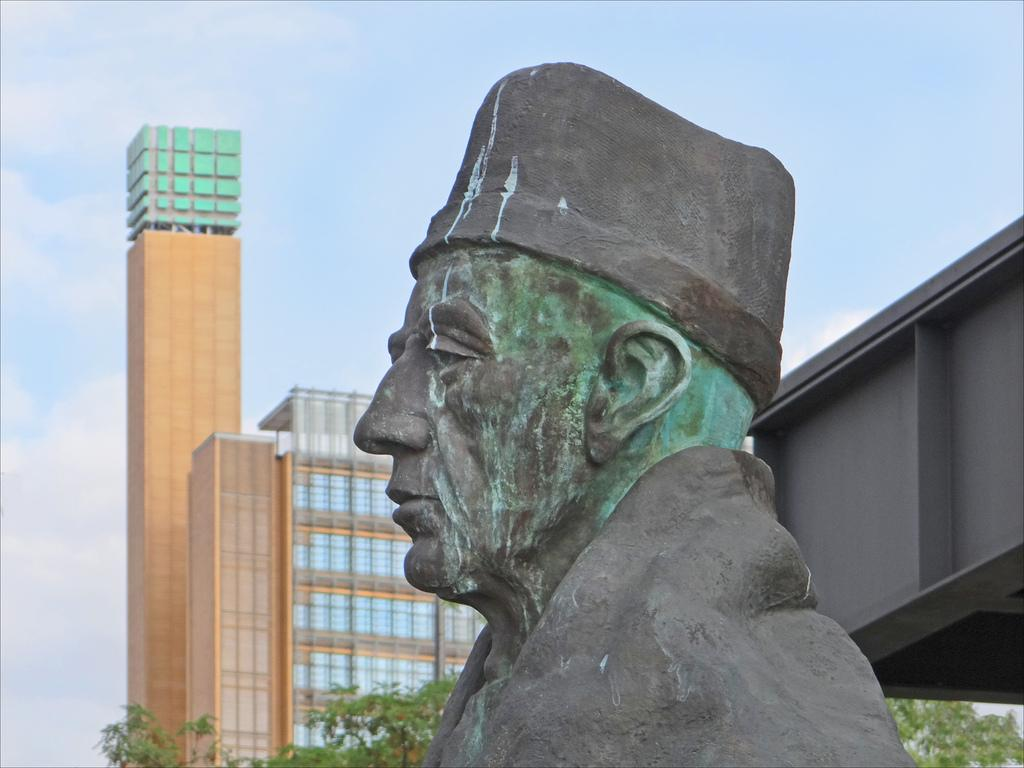What is the main subject of the image? There is a sculpture of a person in the image. What else can be seen in the image besides the sculpture? There is a building and a tree in the image. How would you describe the sky in the image? The sky is cloudy in the image. What type of wrench is being used to adjust the steam coming from the sculpture in the image? There is no wrench or steam present in the image; it features a sculpture of a person, a building, a tree, and a cloudy sky. 